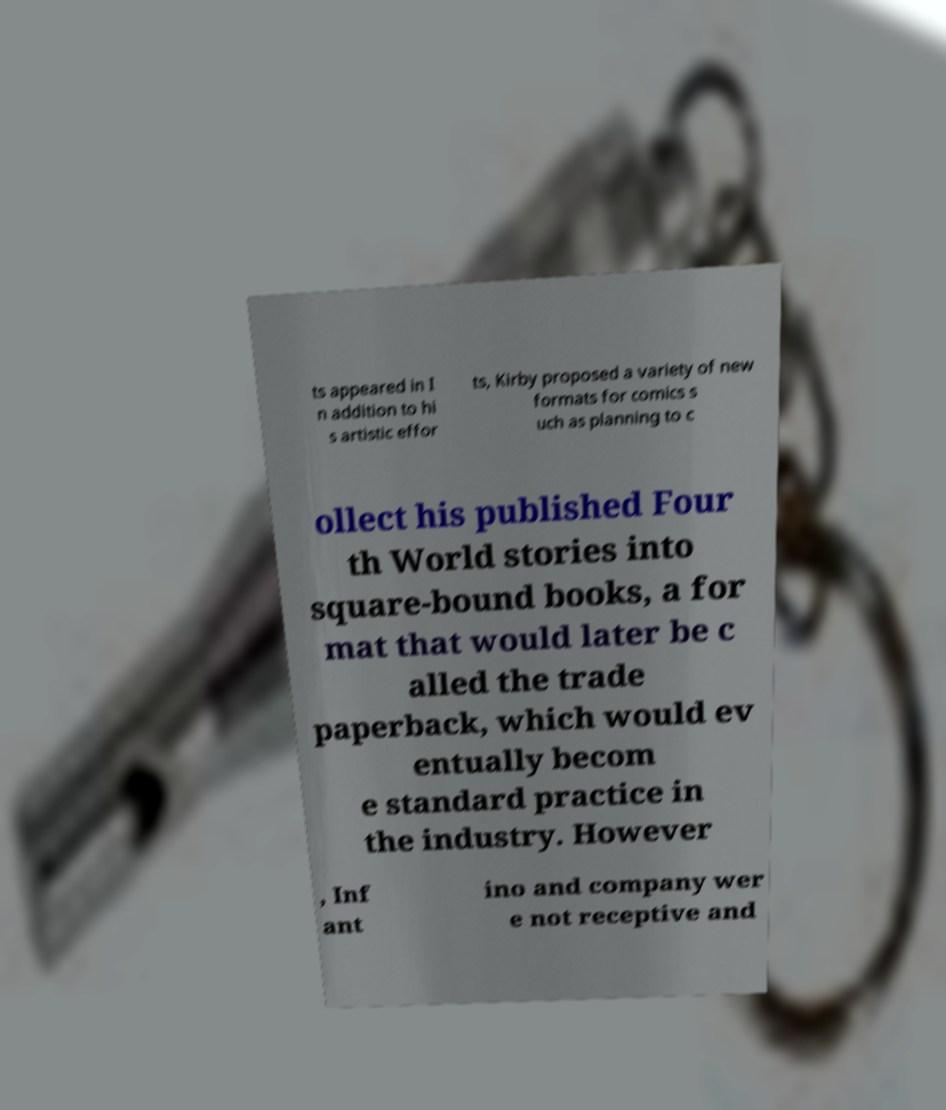What messages or text are displayed in this image? I need them in a readable, typed format. ts appeared in I n addition to hi s artistic effor ts, Kirby proposed a variety of new formats for comics s uch as planning to c ollect his published Four th World stories into square-bound books, a for mat that would later be c alled the trade paperback, which would ev entually becom e standard practice in the industry. However , Inf ant ino and company wer e not receptive and 